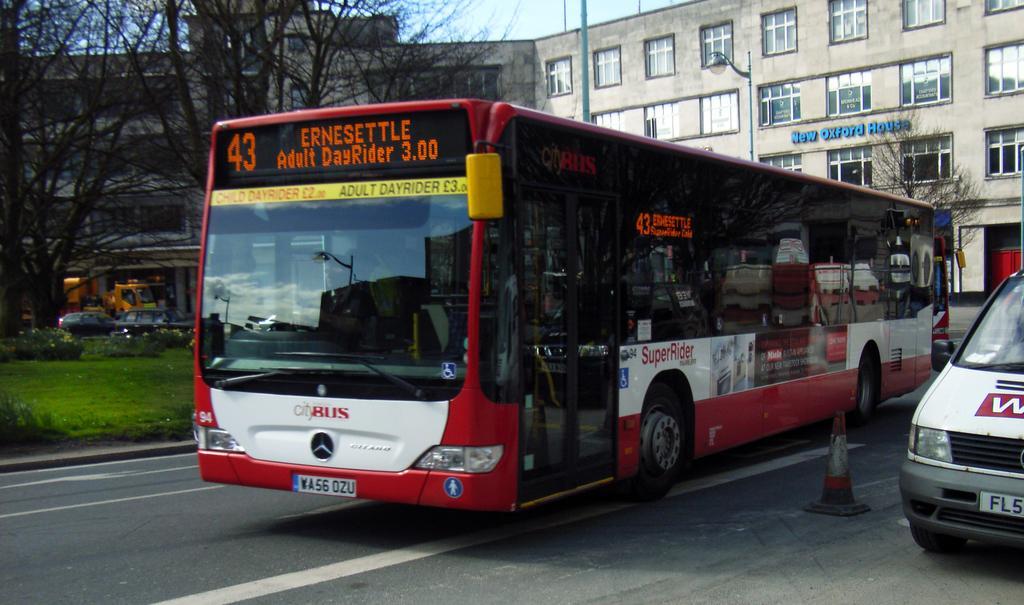In one or two sentences, can you explain what this image depicts? In this image we can see a bus on the road and we can also see some vehicles on the road. In the background, we can see a building and we can also see some trees, plants and grass on the ground. We can also see the sky. 